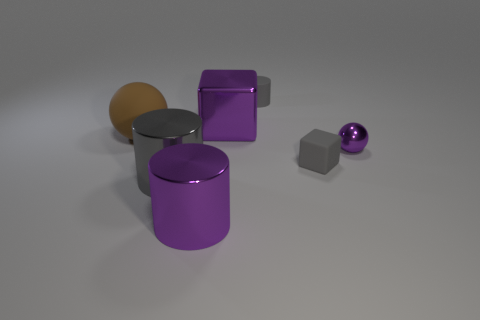How do the textures and lighting in this image contribute to the overall aesthetic? The textures are quite smooth and metallic, suggesting a clean, modern aesthetic. The lighting is soft and diffused, providing gentle shadows and subtle reflections on the surfaces, which enhances the three-dimensional quality of the objects and adds to the tranquil and sleek design of the scene. 